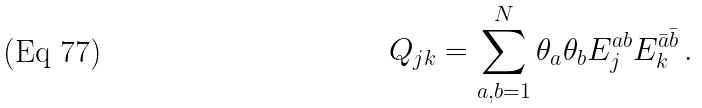Convert formula to latex. <formula><loc_0><loc_0><loc_500><loc_500>Q _ { j k } = \sum _ { a , b = 1 } ^ { N } \theta _ { a } \theta _ { b } E ^ { a b } _ { j } E ^ { \bar { a } \bar { b } } _ { k } \, .</formula> 